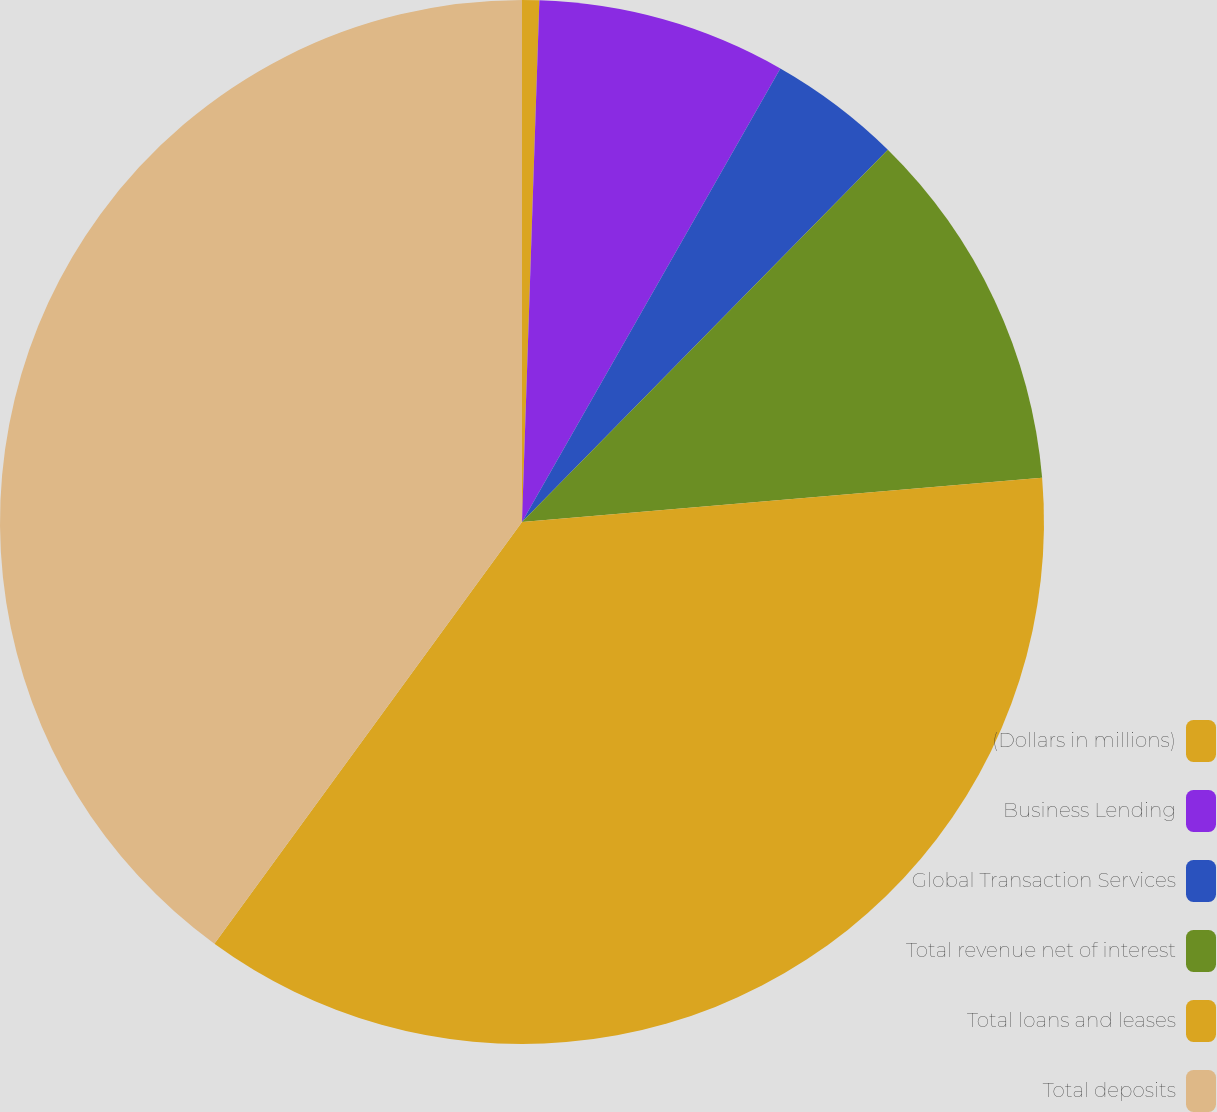Convert chart to OTSL. <chart><loc_0><loc_0><loc_500><loc_500><pie_chart><fcel>(Dollars in millions)<fcel>Business Lending<fcel>Global Transaction Services<fcel>Total revenue net of interest<fcel>Total loans and leases<fcel>Total deposits<nl><fcel>0.53%<fcel>7.71%<fcel>4.12%<fcel>11.29%<fcel>36.38%<fcel>39.97%<nl></chart> 